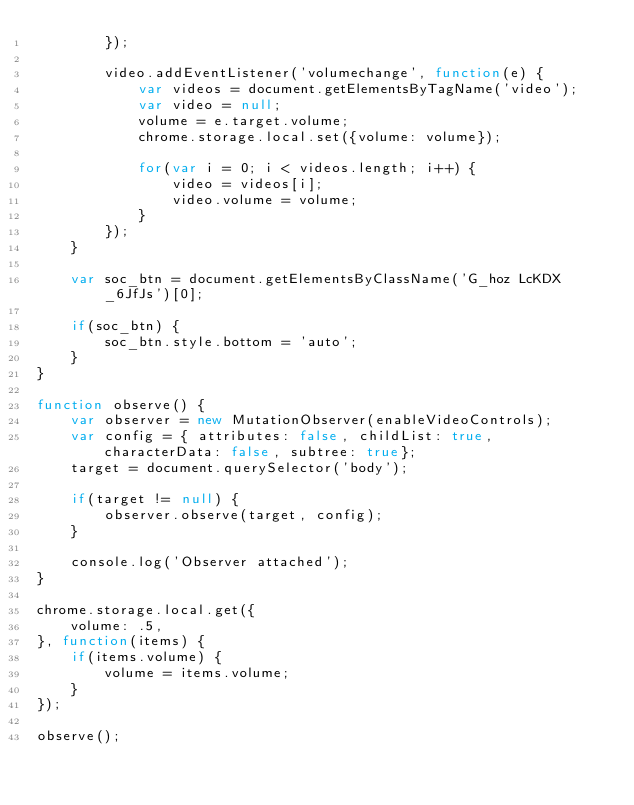<code> <loc_0><loc_0><loc_500><loc_500><_JavaScript_>        });

        video.addEventListener('volumechange', function(e) {
            var videos = document.getElementsByTagName('video');
            var video = null;
            volume = e.target.volume;
            chrome.storage.local.set({volume: volume});

            for(var i = 0; i < videos.length; i++) {
                video = videos[i];
                video.volume = volume;
            }
        });
    }

    var soc_btn = document.getElementsByClassName('G_hoz LcKDX _6JfJs')[0];

    if(soc_btn) {
        soc_btn.style.bottom = 'auto';
    }
}

function observe() {
    var observer = new MutationObserver(enableVideoControls);
    var config = { attributes: false, childList: true, characterData: false, subtree: true};
    target = document.querySelector('body');

    if(target != null) {
        observer.observe(target, config);
    }

    console.log('Observer attached');
}

chrome.storage.local.get({
    volume: .5,
}, function(items) {
    if(items.volume) {
        volume = items.volume;
    }
});

observe();
</code> 